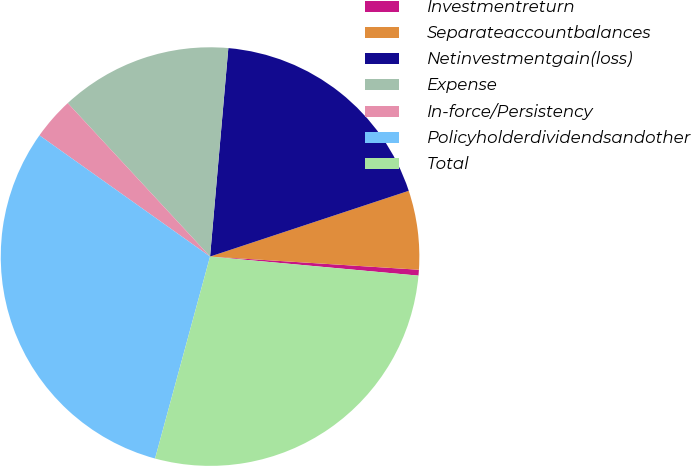Convert chart. <chart><loc_0><loc_0><loc_500><loc_500><pie_chart><fcel>Investmentreturn<fcel>Separateaccountbalances<fcel>Netinvestmentgain(loss)<fcel>Expense<fcel>In-force/Persistency<fcel>Policyholderdividendsandother<fcel>Total<nl><fcel>0.45%<fcel>6.09%<fcel>18.52%<fcel>13.29%<fcel>3.27%<fcel>30.6%<fcel>27.78%<nl></chart> 